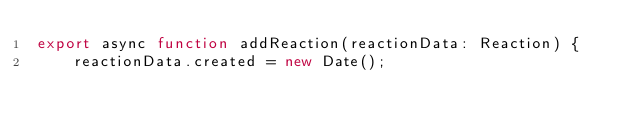<code> <loc_0><loc_0><loc_500><loc_500><_TypeScript_>export async function addReaction(reactionData: Reaction) {
    reactionData.created = new Date();</code> 